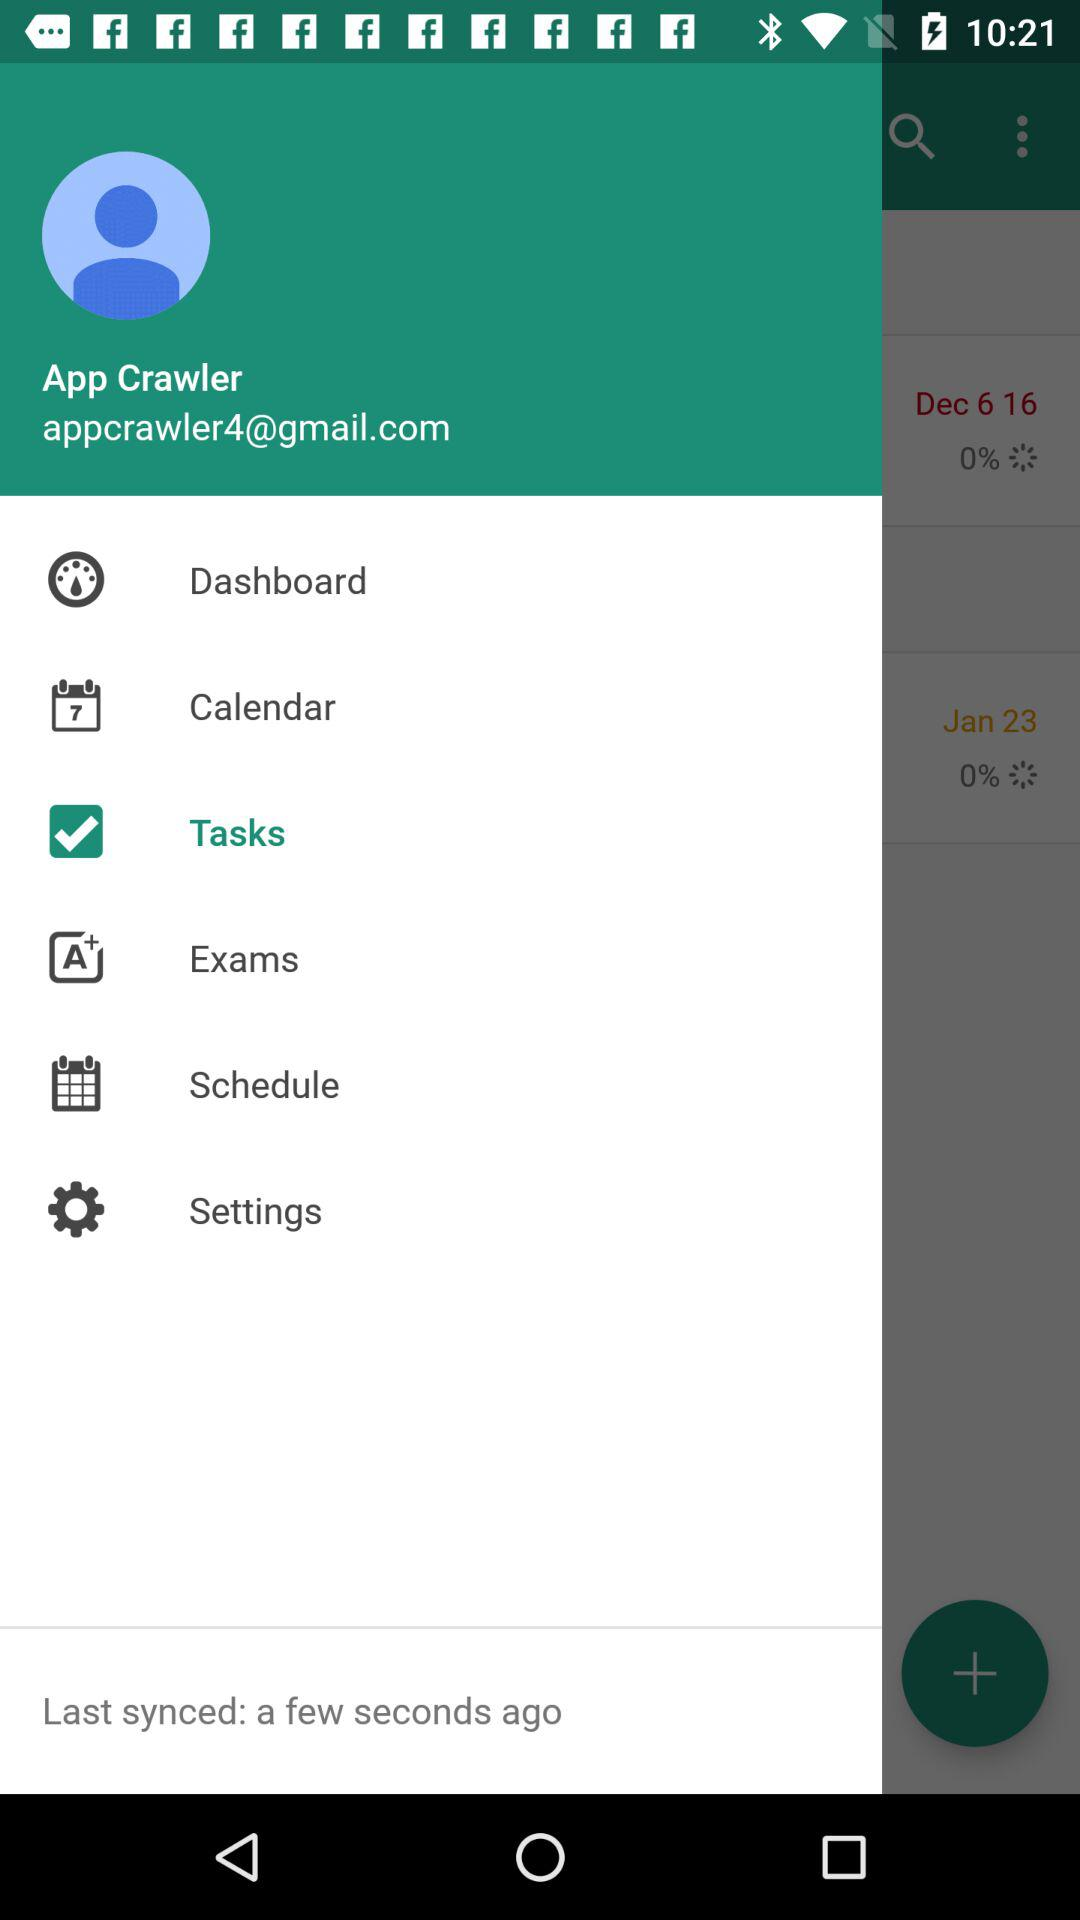Which item has been selected? The item that has been selected is "Tasks". 